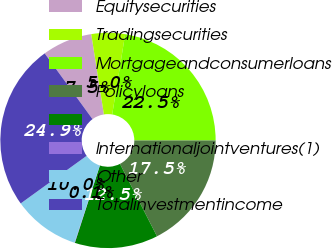Convert chart. <chart><loc_0><loc_0><loc_500><loc_500><pie_chart><fcel>Equitysecurities<fcel>Tradingsecurities<fcel>Mortgageandconsumerloans<fcel>Policyloans<fcel>Unnamed: 4<fcel>Internationaljointventures(1)<fcel>Other<fcel>Totalinvestmentincome<nl><fcel>7.52%<fcel>5.04%<fcel>22.45%<fcel>17.48%<fcel>12.5%<fcel>0.06%<fcel>10.01%<fcel>24.94%<nl></chart> 